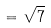<formula> <loc_0><loc_0><loc_500><loc_500>= \sqrt { 7 }</formula> 